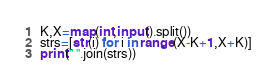<code> <loc_0><loc_0><loc_500><loc_500><_Python_>K,X=map(int,input().split())
strs=[str(i) for i in range(X-K+1,X+K)]
print(" ".join(strs))</code> 